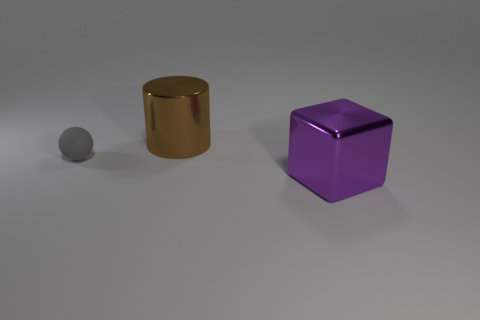Are there an equal number of tiny gray rubber spheres behind the big brown thing and red rubber cylinders?
Ensure brevity in your answer.  Yes. Is the color of the cylinder the same as the big cube?
Your answer should be compact. No. There is a thing that is on the right side of the matte ball and in front of the large brown cylinder; what size is it?
Your response must be concise. Large. There is a cylinder that is made of the same material as the big purple object; what is its color?
Make the answer very short. Brown. What number of other large purple blocks have the same material as the large purple block?
Provide a short and direct response. 0. Are there an equal number of shiny cylinders to the left of the brown metal cylinder and large brown shiny things left of the gray rubber object?
Give a very brief answer. Yes. Do the purple shiny thing and the metallic thing that is left of the purple thing have the same shape?
Make the answer very short. No. Are there any other things that are the same shape as the big purple metallic thing?
Keep it short and to the point. No. Is the material of the large brown cylinder the same as the gray thing left of the big metallic cube?
Provide a short and direct response. No. There is a large thing that is behind the metal thing to the right of the large shiny object that is behind the big purple thing; what is its color?
Offer a terse response. Brown. 